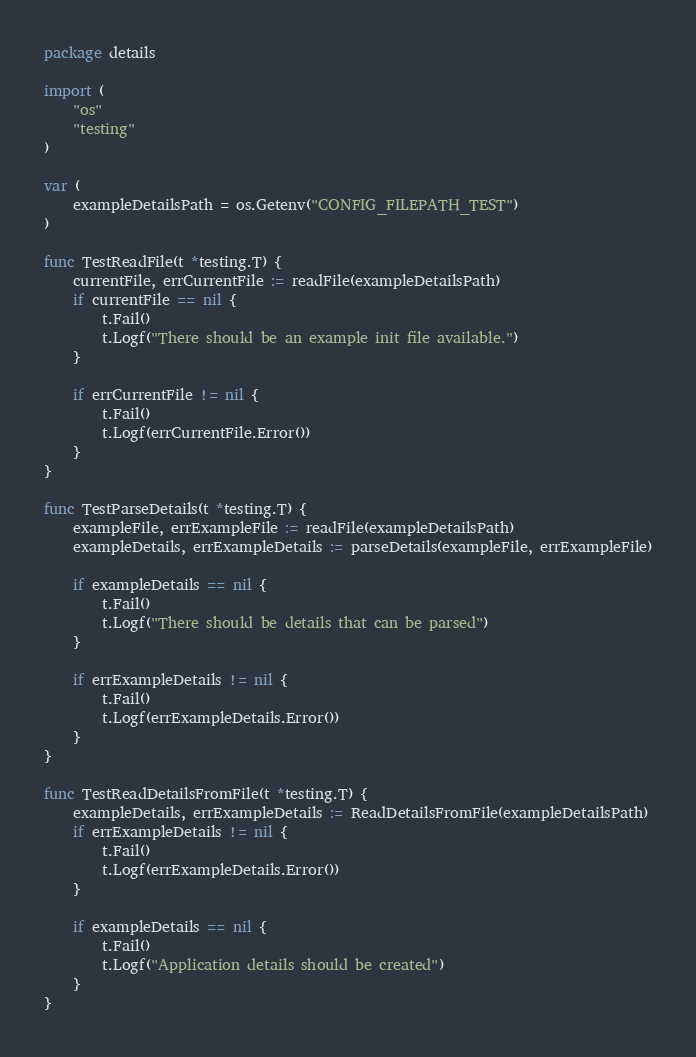<code> <loc_0><loc_0><loc_500><loc_500><_Go_>package details

import (
	"os"
	"testing"
)

var (
	exampleDetailsPath = os.Getenv("CONFIG_FILEPATH_TEST")
)

func TestReadFile(t *testing.T) {
	currentFile, errCurrentFile := readFile(exampleDetailsPath)
	if currentFile == nil {
		t.Fail()
		t.Logf("There should be an example init file available.")
	}

	if errCurrentFile != nil {
		t.Fail()
		t.Logf(errCurrentFile.Error())
	}
}

func TestParseDetails(t *testing.T) {
	exampleFile, errExampleFile := readFile(exampleDetailsPath)
	exampleDetails, errExampleDetails := parseDetails(exampleFile, errExampleFile)

	if exampleDetails == nil {
		t.Fail()
		t.Logf("There should be details that can be parsed")
	}

	if errExampleDetails != nil {
		t.Fail()
		t.Logf(errExampleDetails.Error())
	}
}

func TestReadDetailsFromFile(t *testing.T) {
	exampleDetails, errExampleDetails := ReadDetailsFromFile(exampleDetailsPath)
	if errExampleDetails != nil {
		t.Fail()
		t.Logf(errExampleDetails.Error())
	}

	if exampleDetails == nil {
		t.Fail()
		t.Logf("Application details should be created")
	}
}
</code> 